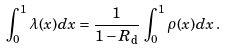Convert formula to latex. <formula><loc_0><loc_0><loc_500><loc_500>\int _ { 0 } ^ { 1 } \lambda ( x ) d x = \frac { 1 } { 1 - R _ { \text {d} } } \, \int _ { 0 } ^ { 1 } \rho ( x ) d x \, .</formula> 